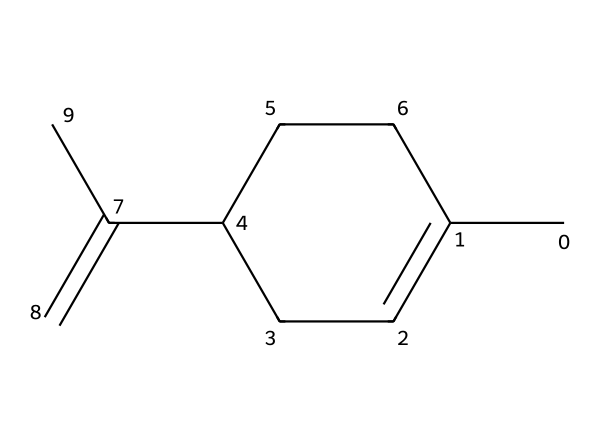How many carbon atoms are in limonene? By examining the SMILES representation, we can count the number of carbon atoms. In the structure CC1=CCC(CC1)C(=C)C, we can find a total of 10 carbon atoms in the main chain and branches.
Answer: 10 What type of bonding is primarily present in limonene? The majority of the bonds in limonene are single bonds, typical for carbon chains, along with double bonds in the alkene part of the structure. We can identify single (C-C) and double (C=C) bonds while looking at the structure.
Answer: single and double Is limonene a cyclic compound? The structure provided shows a ring in the notation (C1), which signifies that there is a cyclical part in limonene. This means that limonene contains a cyclic structure as part of its overall configuration.
Answer: yes What is the functional group present in limonene? The key feature of limonene is the presence of a double bond (alkene). The SMILES indicates this double bond (C=C) which identifies it distinctly as an alkene. Therefore, the functional group can be classified as an alkene.
Answer: alkene How many double bonds are in limonene? By examining the SMILES representation, we can see there is only one double bond in the structure (C=C). Thus, we simply count the visible occurrences of double bonding to answer this question.
Answer: 1 What property do terpenes like limonene generally have? Terpenes such as limonene are volatiles, meaning they easily evaporate at room temperature. This is a common property for such compounds, which can be observed considering their use in essential oils.
Answer: volatility 